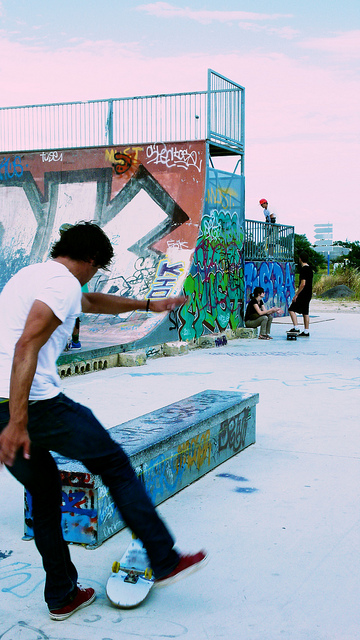Can you describe the graffiti on the ramp? The graffiti on the ramp adds a vivid and colorful accent to the scene, an art form often associated with skate culture. Various tags and artistic expressions in hues of blue, red, yellow, and other assorted colors can be seen covering the structures, creating a backdrop that is both dynamic and expressive, typical of the creative environment found in many urban skateparks. 